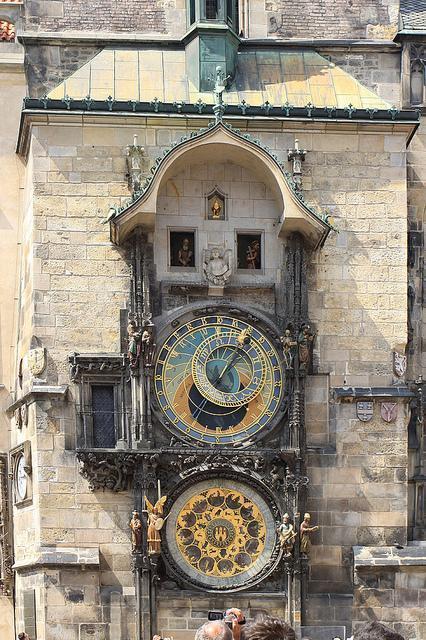How many clocks are visible?
Give a very brief answer. 2. 